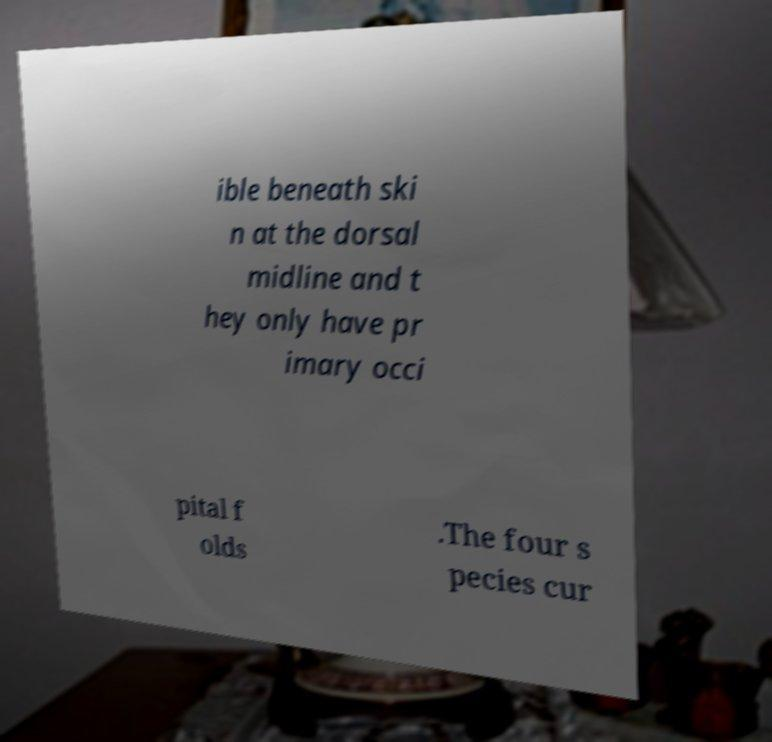What messages or text are displayed in this image? I need them in a readable, typed format. ible beneath ski n at the dorsal midline and t hey only have pr imary occi pital f olds .The four s pecies cur 